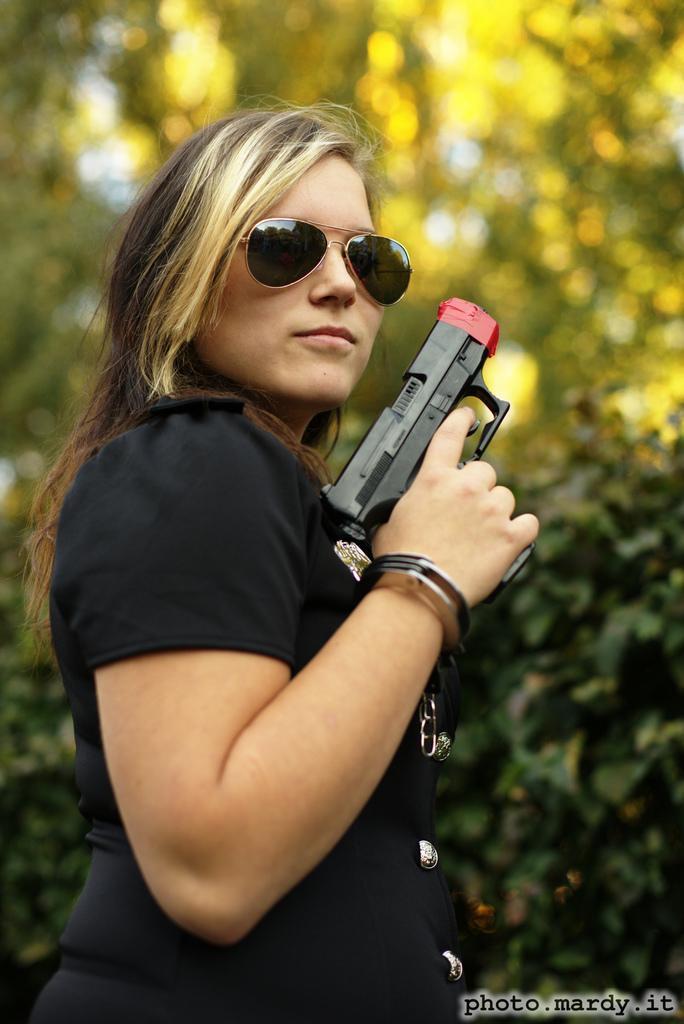In one or two sentences, can you explain what this image depicts? In this image there is a person holding a gun, there is text towards the bottom of the image, there are trees in the background of the image. 